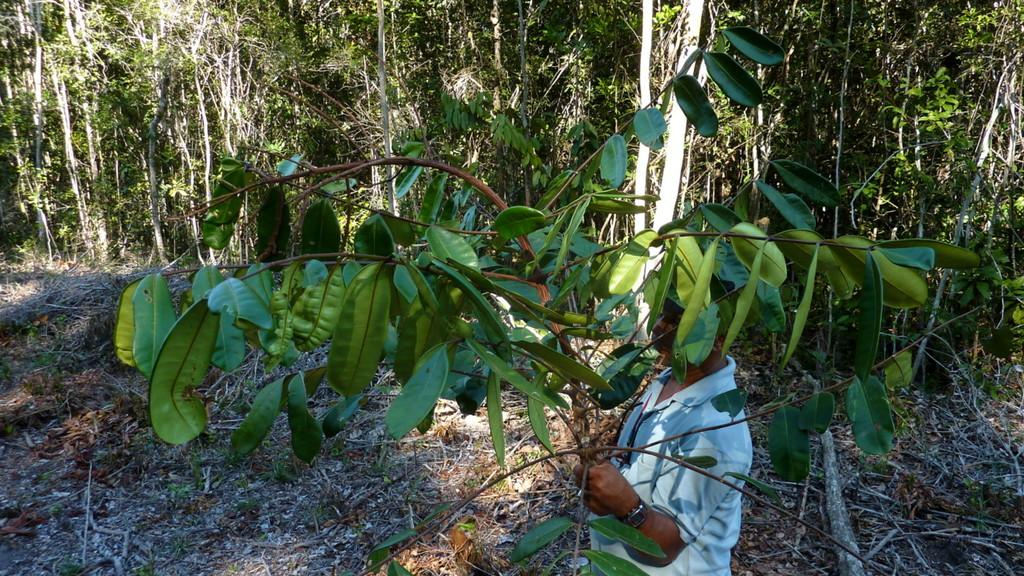Who or what is present in the image? There is a person in the image. What is the person holding in the image? The person is holding a tree branch. What can be seen in the background of the image? There are trees in the background of the image. What type of vegetation can be seen at the bottom of the image? Dry leaves are present at the bottom of the image. What song is the person singing in the image? There is no indication in the image that the person is singing a song, so it cannot be determined from the picture. 